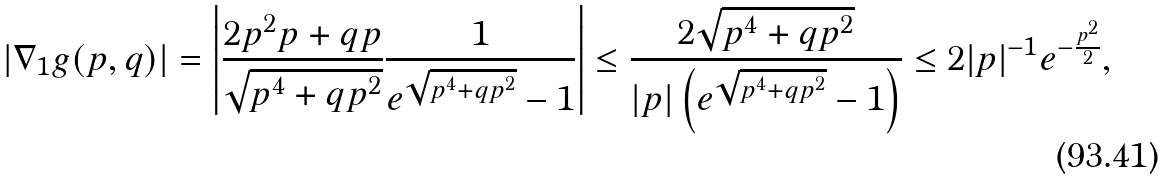<formula> <loc_0><loc_0><loc_500><loc_500>| \nabla _ { 1 } g ( p , q ) | & = \left | \frac { 2 p ^ { 2 } p + q p } { \sqrt { p ^ { 4 } + q p ^ { 2 } } } \frac { 1 } { e ^ { \sqrt { p ^ { 4 } + q p ^ { 2 } } } - 1 } \right | \leq \frac { 2 \sqrt { p ^ { 4 } + q p ^ { 2 } } } { | p | \left ( e ^ { \sqrt { p ^ { 4 } + q p ^ { 2 } } } - 1 \right ) } \leq 2 | p | ^ { - 1 } e ^ { - \frac { p ^ { 2 } } { 2 } } ,</formula> 